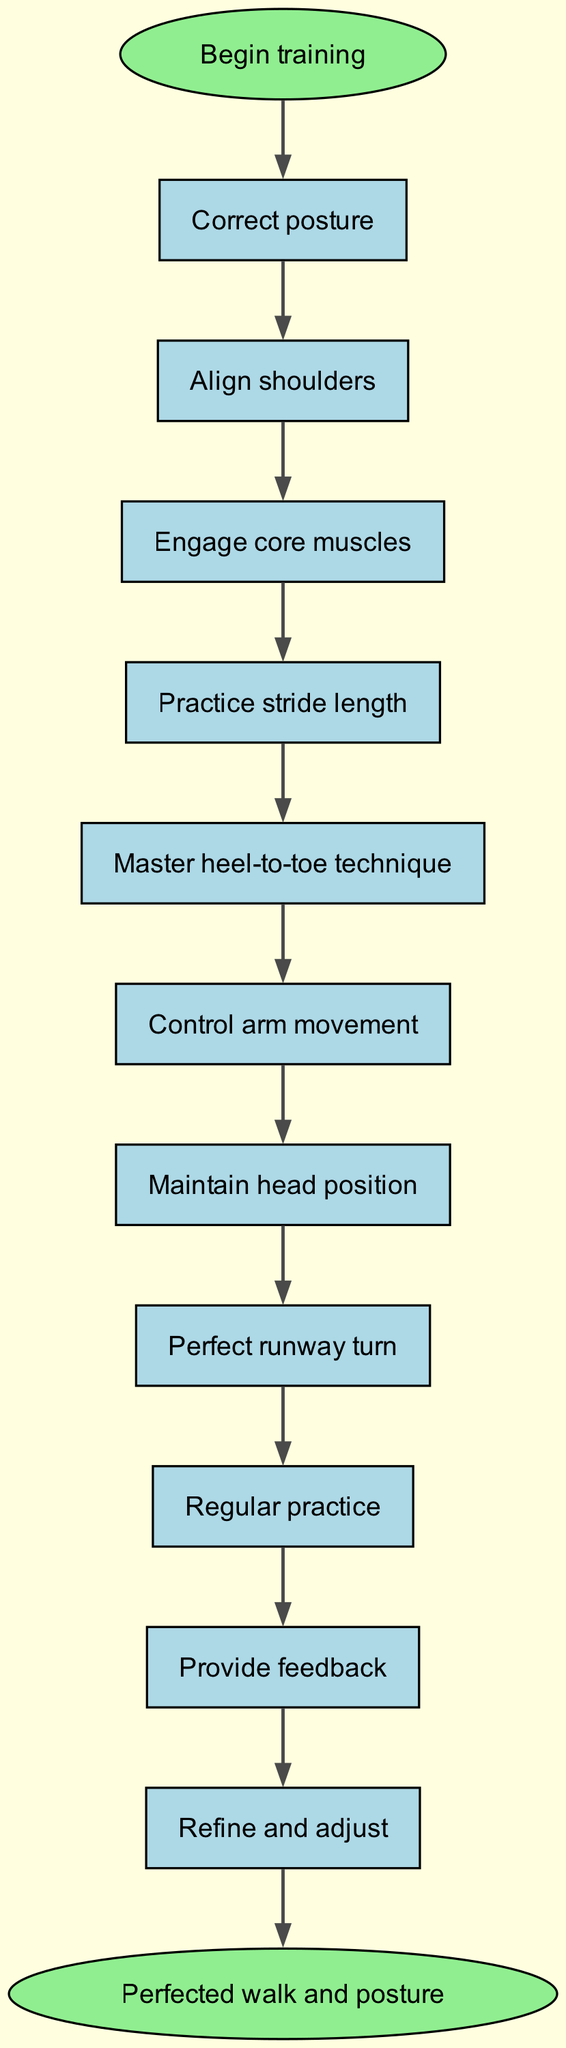What is the first step in the flow chart? The flow chart shows that the first step is "Begin training." This is indicated by the node labeled "start," which directs to the first activity in the training process.
Answer: Begin training How many nodes are there in the diagram? By counting all the labeled boxes in the flow chart including the start and end points, there are a total of 13 nodes present.
Answer: 13 What follows "Engage core muscles"? The flow chart shows that "Practice stride length" follows "Engage core muscles." This can be traced by looking at the directed arrows leading from one node to the next consecutive node.
Answer: Practice stride length Which two steps are connected by feedback? The flow chart indicates that "Regular practice" is connected to "Provide feedback," meaning they are sequential steps in the process, linked by an arrow that points from the first to the second.
Answer: Regular practice and Provide feedback What is the last step before the “Perfected walk and posture”? The step before "Perfected walk and posture" is "Refine and adjust," which is the penultimate action to take before reaching the final outcome in the flow chart.
Answer: Refine and adjust What is the relationship between "Control arm movement" and "Maintain head position"? "Control arm movement" directly leads to "Maintain head position," as depicted by an arrow connecting the two nodes, indicating the sequence of steps in the flow for perfecting the walk.
Answer: Directly leads to What step comes after mastering heel-to-toe technique? According to the flow chart, "Control arm movement" comes right after "Master heel-to-toe technique," which follows the established sequence of the training activities.
Answer: Control arm movement Which step involves regular practice? The step that involves regular practice is labeled "Regular practice," which is explicitly stated as a necessary action in the process to improve the contestant's walk and posture.
Answer: Regular practice What is the purpose of the "Provide feedback" step? The "Provide feedback" step is intended to give performance assessments to the contestant after the "Regular practice" session, emphasizing the importance of feedback in the training process.
Answer: To give performance assessments 